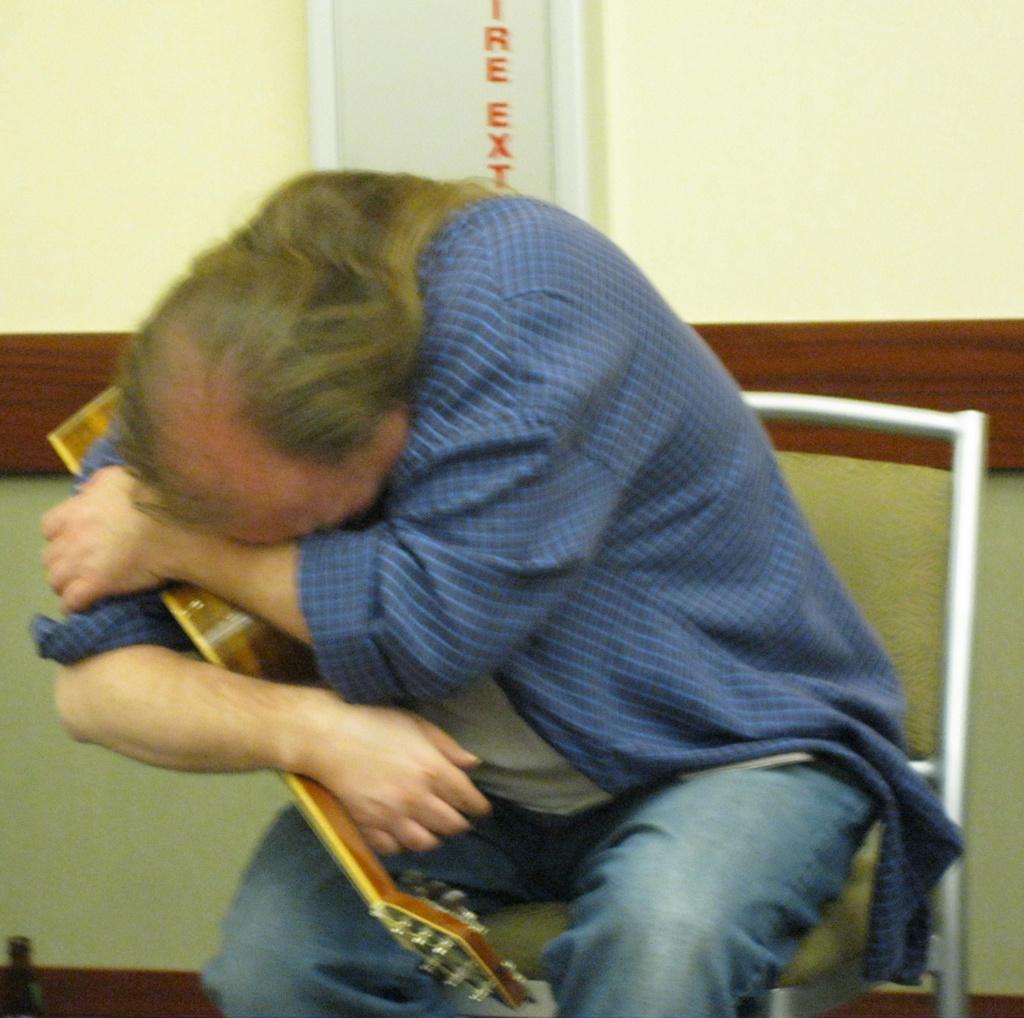Please provide a concise description of this image. A man is holding guitar tightly. 